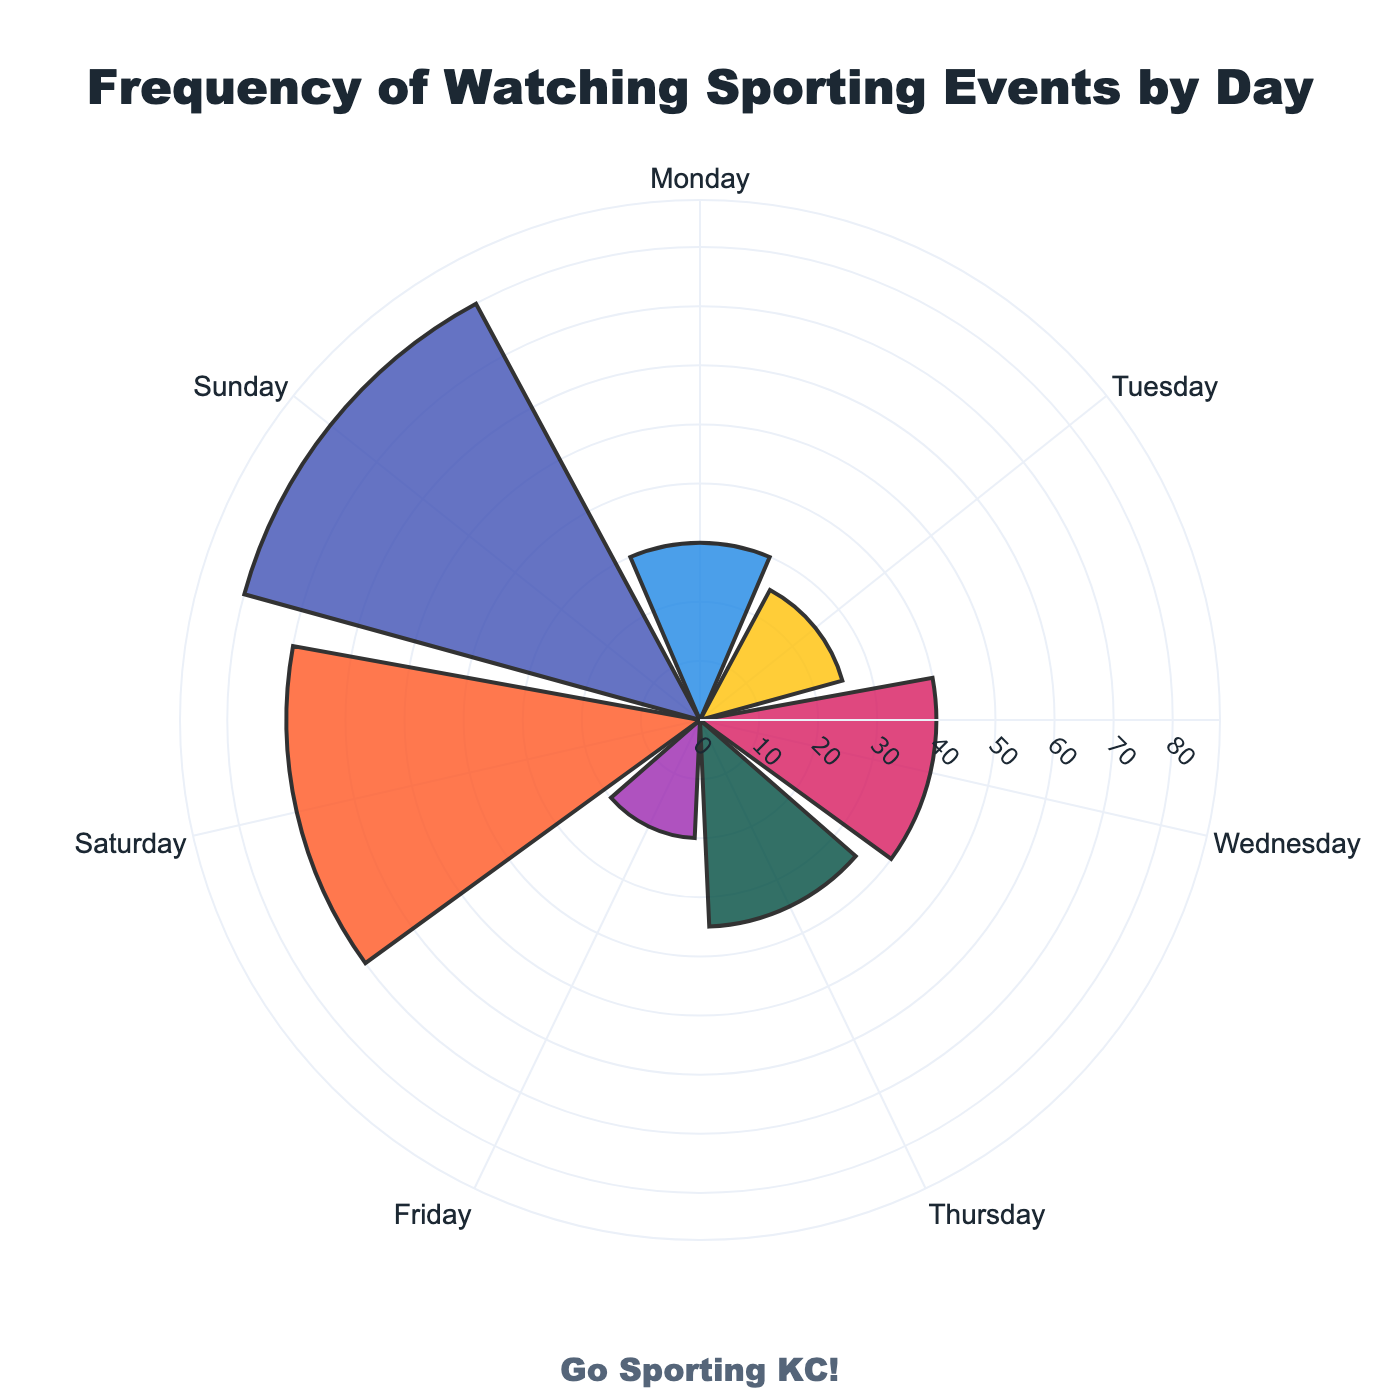What is the title of the chart? The title is at the top center of the chart and it reads "Frequency of Watching Sporting Events by Day".
Answer: Frequency of Watching Sporting Events by Day What day has the highest frequency of watching sporting events? By looking at the bars, the longest bar corresponds to Sunday, indicating the highest frequency.
Answer: Sunday How many data points (days) are represented in the chart? The chart displays one bar for each day of the week, making it seven data points in total.
Answer: Seven What is the frequency of watching sporting events on Monday? The bar corresponding to Monday has a labeled value, which is 30.
Answer: 30 Which day shows the least frequency of watching sporting events? The day with the shortest bar is Friday, as its bar is the smallest.
Answer: Friday What is the total frequency of watching sporting events from Friday to Sunday? Add the frequencies for Friday (20), Saturday (70), and Sunday (80). The total is 20 + 70 + 80 = 170.
Answer: 170 What is the average frequency of watching sporting events on weekdays (Monday to Friday)? Add the frequencies for Monday (30), Tuesday (25), Wednesday (40), Thursday (35), and Friday (20), then divide by 5. The sum is 30 + 25 + 40 + 35 + 20 = 150. The average is 150 / 5 = 30.
Answer: 30 On which weekend day (Saturday or Sunday) do people watch more sporting events? Comparing the bars for Saturday (70) and Sunday (80), the bar is longer for Sunday, indicating higher frequency.
Answer: Sunday Is the frequency of watching sporting events on Thursday greater than on Tuesday? Compare the bars for Thursday (35) and Tuesday (25). The bar for Thursday is longer, indicating a higher frequency.
Answer: Yes What is the median frequency of watching sporting events throughout the week? Sorting the frequencies: 20 (Friday), 25 (Tuesday), 30 (Monday), 35 (Thursday), 40 (Wednesday), 70 (Saturday), 80 (Sunday). The median frequency is the middle value, which is 35.
Answer: 35 